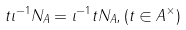<formula> <loc_0><loc_0><loc_500><loc_500>t \iota ^ { - 1 } N _ { A } = \iota ^ { - 1 } t N _ { A } , ( t \in A ^ { \times } )</formula> 